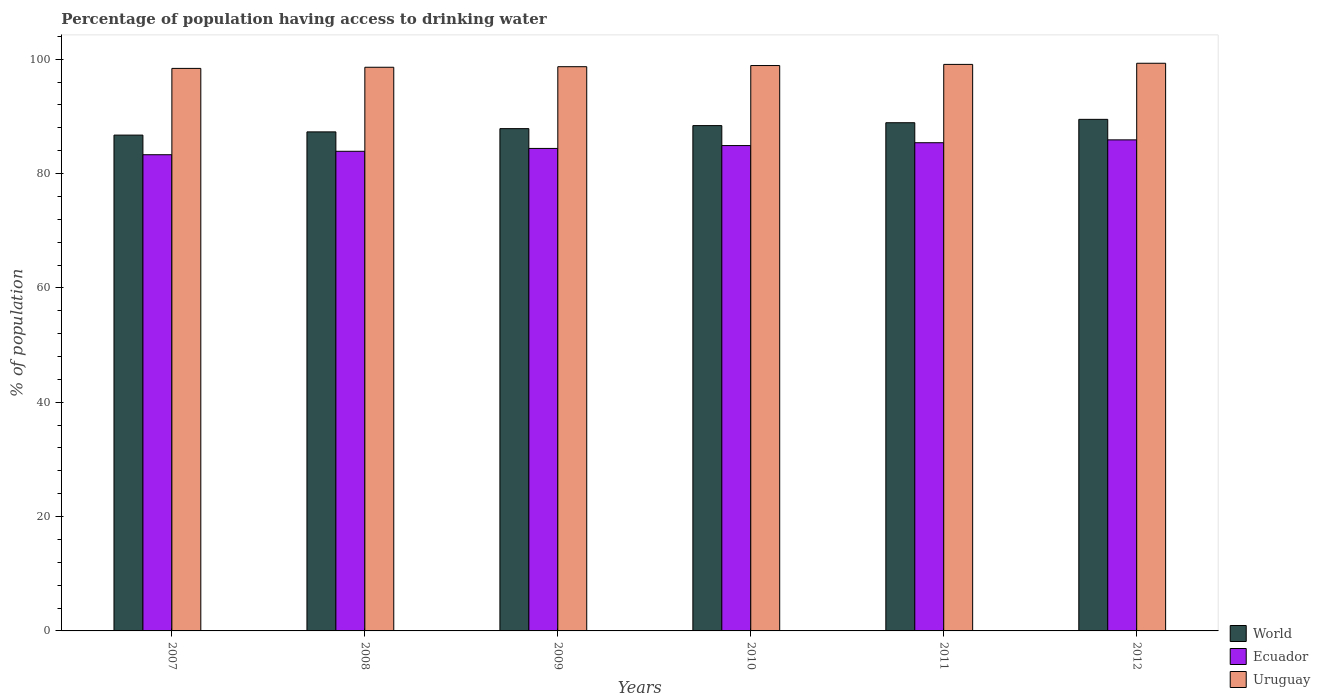How many different coloured bars are there?
Provide a succinct answer. 3. Are the number of bars per tick equal to the number of legend labels?
Offer a very short reply. Yes. How many bars are there on the 5th tick from the left?
Your answer should be compact. 3. How many bars are there on the 6th tick from the right?
Your response must be concise. 3. What is the label of the 4th group of bars from the left?
Your response must be concise. 2010. In how many cases, is the number of bars for a given year not equal to the number of legend labels?
Provide a succinct answer. 0. What is the percentage of population having access to drinking water in World in 2009?
Ensure brevity in your answer.  87.86. Across all years, what is the maximum percentage of population having access to drinking water in Ecuador?
Keep it short and to the point. 85.9. Across all years, what is the minimum percentage of population having access to drinking water in World?
Keep it short and to the point. 86.73. In which year was the percentage of population having access to drinking water in Uruguay minimum?
Your answer should be very brief. 2007. What is the total percentage of population having access to drinking water in Uruguay in the graph?
Provide a short and direct response. 593. What is the difference between the percentage of population having access to drinking water in Uruguay in 2009 and that in 2011?
Offer a terse response. -0.4. What is the difference between the percentage of population having access to drinking water in Uruguay in 2007 and the percentage of population having access to drinking water in World in 2012?
Your answer should be compact. 8.91. What is the average percentage of population having access to drinking water in Uruguay per year?
Keep it short and to the point. 98.83. In the year 2008, what is the difference between the percentage of population having access to drinking water in Ecuador and percentage of population having access to drinking water in World?
Make the answer very short. -3.4. In how many years, is the percentage of population having access to drinking water in World greater than 28 %?
Ensure brevity in your answer.  6. What is the ratio of the percentage of population having access to drinking water in Uruguay in 2008 to that in 2010?
Make the answer very short. 1. Is the percentage of population having access to drinking water in Uruguay in 2008 less than that in 2011?
Your response must be concise. Yes. Is the difference between the percentage of population having access to drinking water in Ecuador in 2010 and 2012 greater than the difference between the percentage of population having access to drinking water in World in 2010 and 2012?
Keep it short and to the point. Yes. What is the difference between the highest and the second highest percentage of population having access to drinking water in Uruguay?
Your answer should be compact. 0.2. What is the difference between the highest and the lowest percentage of population having access to drinking water in World?
Provide a succinct answer. 2.76. What does the 3rd bar from the left in 2010 represents?
Your answer should be compact. Uruguay. What does the 3rd bar from the right in 2011 represents?
Your response must be concise. World. How many years are there in the graph?
Provide a succinct answer. 6. Where does the legend appear in the graph?
Make the answer very short. Bottom right. How many legend labels are there?
Keep it short and to the point. 3. How are the legend labels stacked?
Give a very brief answer. Vertical. What is the title of the graph?
Your answer should be compact. Percentage of population having access to drinking water. Does "Greenland" appear as one of the legend labels in the graph?
Your answer should be compact. No. What is the label or title of the X-axis?
Offer a terse response. Years. What is the label or title of the Y-axis?
Give a very brief answer. % of population. What is the % of population in World in 2007?
Your response must be concise. 86.73. What is the % of population of Ecuador in 2007?
Provide a succinct answer. 83.3. What is the % of population of Uruguay in 2007?
Provide a succinct answer. 98.4. What is the % of population of World in 2008?
Your answer should be compact. 87.3. What is the % of population in Ecuador in 2008?
Offer a terse response. 83.9. What is the % of population of Uruguay in 2008?
Provide a succinct answer. 98.6. What is the % of population in World in 2009?
Your answer should be very brief. 87.86. What is the % of population of Ecuador in 2009?
Offer a very short reply. 84.4. What is the % of population of Uruguay in 2009?
Offer a very short reply. 98.7. What is the % of population of World in 2010?
Your answer should be very brief. 88.39. What is the % of population of Ecuador in 2010?
Make the answer very short. 84.9. What is the % of population in Uruguay in 2010?
Your answer should be very brief. 98.9. What is the % of population of World in 2011?
Your answer should be very brief. 88.9. What is the % of population in Ecuador in 2011?
Give a very brief answer. 85.4. What is the % of population in Uruguay in 2011?
Provide a short and direct response. 99.1. What is the % of population in World in 2012?
Offer a terse response. 89.49. What is the % of population of Ecuador in 2012?
Give a very brief answer. 85.9. What is the % of population of Uruguay in 2012?
Make the answer very short. 99.3. Across all years, what is the maximum % of population of World?
Offer a terse response. 89.49. Across all years, what is the maximum % of population in Ecuador?
Offer a very short reply. 85.9. Across all years, what is the maximum % of population in Uruguay?
Ensure brevity in your answer.  99.3. Across all years, what is the minimum % of population of World?
Offer a terse response. 86.73. Across all years, what is the minimum % of population of Ecuador?
Provide a succinct answer. 83.3. Across all years, what is the minimum % of population of Uruguay?
Provide a short and direct response. 98.4. What is the total % of population in World in the graph?
Offer a terse response. 528.67. What is the total % of population in Ecuador in the graph?
Make the answer very short. 507.8. What is the total % of population in Uruguay in the graph?
Give a very brief answer. 593. What is the difference between the % of population in World in 2007 and that in 2008?
Ensure brevity in your answer.  -0.56. What is the difference between the % of population in Ecuador in 2007 and that in 2008?
Make the answer very short. -0.6. What is the difference between the % of population in Uruguay in 2007 and that in 2008?
Ensure brevity in your answer.  -0.2. What is the difference between the % of population of World in 2007 and that in 2009?
Your answer should be compact. -1.13. What is the difference between the % of population in Ecuador in 2007 and that in 2009?
Your answer should be very brief. -1.1. What is the difference between the % of population in Uruguay in 2007 and that in 2009?
Ensure brevity in your answer.  -0.3. What is the difference between the % of population of World in 2007 and that in 2010?
Make the answer very short. -1.66. What is the difference between the % of population in Uruguay in 2007 and that in 2010?
Ensure brevity in your answer.  -0.5. What is the difference between the % of population of World in 2007 and that in 2011?
Give a very brief answer. -2.17. What is the difference between the % of population of Uruguay in 2007 and that in 2011?
Offer a terse response. -0.7. What is the difference between the % of population of World in 2007 and that in 2012?
Your answer should be very brief. -2.76. What is the difference between the % of population of World in 2008 and that in 2009?
Make the answer very short. -0.57. What is the difference between the % of population of Ecuador in 2008 and that in 2009?
Your answer should be compact. -0.5. What is the difference between the % of population in Uruguay in 2008 and that in 2009?
Offer a very short reply. -0.1. What is the difference between the % of population of World in 2008 and that in 2010?
Offer a terse response. -1.1. What is the difference between the % of population in World in 2008 and that in 2011?
Give a very brief answer. -1.6. What is the difference between the % of population in World in 2008 and that in 2012?
Your answer should be very brief. -2.19. What is the difference between the % of population of Ecuador in 2008 and that in 2012?
Offer a terse response. -2. What is the difference between the % of population of World in 2009 and that in 2010?
Make the answer very short. -0.53. What is the difference between the % of population of Uruguay in 2009 and that in 2010?
Make the answer very short. -0.2. What is the difference between the % of population of World in 2009 and that in 2011?
Your answer should be very brief. -1.03. What is the difference between the % of population in Uruguay in 2009 and that in 2011?
Keep it short and to the point. -0.4. What is the difference between the % of population of World in 2009 and that in 2012?
Your answer should be very brief. -1.62. What is the difference between the % of population in Ecuador in 2009 and that in 2012?
Your answer should be very brief. -1.5. What is the difference between the % of population in World in 2010 and that in 2011?
Your answer should be compact. -0.5. What is the difference between the % of population of Uruguay in 2010 and that in 2011?
Offer a terse response. -0.2. What is the difference between the % of population in World in 2010 and that in 2012?
Make the answer very short. -1.09. What is the difference between the % of population in World in 2011 and that in 2012?
Offer a terse response. -0.59. What is the difference between the % of population of Ecuador in 2011 and that in 2012?
Provide a succinct answer. -0.5. What is the difference between the % of population in World in 2007 and the % of population in Ecuador in 2008?
Provide a short and direct response. 2.83. What is the difference between the % of population in World in 2007 and the % of population in Uruguay in 2008?
Make the answer very short. -11.87. What is the difference between the % of population in Ecuador in 2007 and the % of population in Uruguay in 2008?
Ensure brevity in your answer.  -15.3. What is the difference between the % of population of World in 2007 and the % of population of Ecuador in 2009?
Offer a very short reply. 2.33. What is the difference between the % of population in World in 2007 and the % of population in Uruguay in 2009?
Your answer should be very brief. -11.97. What is the difference between the % of population in Ecuador in 2007 and the % of population in Uruguay in 2009?
Provide a short and direct response. -15.4. What is the difference between the % of population in World in 2007 and the % of population in Ecuador in 2010?
Your answer should be compact. 1.83. What is the difference between the % of population of World in 2007 and the % of population of Uruguay in 2010?
Make the answer very short. -12.17. What is the difference between the % of population of Ecuador in 2007 and the % of population of Uruguay in 2010?
Give a very brief answer. -15.6. What is the difference between the % of population in World in 2007 and the % of population in Ecuador in 2011?
Give a very brief answer. 1.33. What is the difference between the % of population of World in 2007 and the % of population of Uruguay in 2011?
Ensure brevity in your answer.  -12.37. What is the difference between the % of population of Ecuador in 2007 and the % of population of Uruguay in 2011?
Offer a terse response. -15.8. What is the difference between the % of population in World in 2007 and the % of population in Ecuador in 2012?
Provide a short and direct response. 0.83. What is the difference between the % of population in World in 2007 and the % of population in Uruguay in 2012?
Offer a terse response. -12.57. What is the difference between the % of population of Ecuador in 2007 and the % of population of Uruguay in 2012?
Ensure brevity in your answer.  -16. What is the difference between the % of population of World in 2008 and the % of population of Ecuador in 2009?
Your answer should be very brief. 2.9. What is the difference between the % of population in World in 2008 and the % of population in Uruguay in 2009?
Ensure brevity in your answer.  -11.4. What is the difference between the % of population in Ecuador in 2008 and the % of population in Uruguay in 2009?
Make the answer very short. -14.8. What is the difference between the % of population of World in 2008 and the % of population of Ecuador in 2010?
Make the answer very short. 2.4. What is the difference between the % of population in World in 2008 and the % of population in Uruguay in 2010?
Make the answer very short. -11.6. What is the difference between the % of population in Ecuador in 2008 and the % of population in Uruguay in 2010?
Your answer should be very brief. -15. What is the difference between the % of population of World in 2008 and the % of population of Ecuador in 2011?
Give a very brief answer. 1.9. What is the difference between the % of population of World in 2008 and the % of population of Uruguay in 2011?
Offer a terse response. -11.8. What is the difference between the % of population in Ecuador in 2008 and the % of population in Uruguay in 2011?
Provide a short and direct response. -15.2. What is the difference between the % of population of World in 2008 and the % of population of Ecuador in 2012?
Keep it short and to the point. 1.4. What is the difference between the % of population of World in 2008 and the % of population of Uruguay in 2012?
Your answer should be very brief. -12. What is the difference between the % of population of Ecuador in 2008 and the % of population of Uruguay in 2012?
Your response must be concise. -15.4. What is the difference between the % of population in World in 2009 and the % of population in Ecuador in 2010?
Give a very brief answer. 2.96. What is the difference between the % of population of World in 2009 and the % of population of Uruguay in 2010?
Your answer should be compact. -11.04. What is the difference between the % of population in World in 2009 and the % of population in Ecuador in 2011?
Provide a succinct answer. 2.46. What is the difference between the % of population of World in 2009 and the % of population of Uruguay in 2011?
Keep it short and to the point. -11.24. What is the difference between the % of population of Ecuador in 2009 and the % of population of Uruguay in 2011?
Give a very brief answer. -14.7. What is the difference between the % of population of World in 2009 and the % of population of Ecuador in 2012?
Provide a short and direct response. 1.96. What is the difference between the % of population of World in 2009 and the % of population of Uruguay in 2012?
Provide a succinct answer. -11.44. What is the difference between the % of population in Ecuador in 2009 and the % of population in Uruguay in 2012?
Offer a terse response. -14.9. What is the difference between the % of population of World in 2010 and the % of population of Ecuador in 2011?
Your response must be concise. 2.99. What is the difference between the % of population in World in 2010 and the % of population in Uruguay in 2011?
Offer a terse response. -10.71. What is the difference between the % of population in World in 2010 and the % of population in Ecuador in 2012?
Make the answer very short. 2.49. What is the difference between the % of population of World in 2010 and the % of population of Uruguay in 2012?
Offer a terse response. -10.91. What is the difference between the % of population of Ecuador in 2010 and the % of population of Uruguay in 2012?
Make the answer very short. -14.4. What is the difference between the % of population of World in 2011 and the % of population of Ecuador in 2012?
Your answer should be compact. 3. What is the difference between the % of population in World in 2011 and the % of population in Uruguay in 2012?
Keep it short and to the point. -10.4. What is the average % of population of World per year?
Provide a succinct answer. 88.11. What is the average % of population of Ecuador per year?
Your answer should be very brief. 84.63. What is the average % of population in Uruguay per year?
Make the answer very short. 98.83. In the year 2007, what is the difference between the % of population of World and % of population of Ecuador?
Your answer should be compact. 3.43. In the year 2007, what is the difference between the % of population in World and % of population in Uruguay?
Offer a terse response. -11.67. In the year 2007, what is the difference between the % of population in Ecuador and % of population in Uruguay?
Make the answer very short. -15.1. In the year 2008, what is the difference between the % of population in World and % of population in Ecuador?
Your answer should be very brief. 3.4. In the year 2008, what is the difference between the % of population in World and % of population in Uruguay?
Offer a very short reply. -11.3. In the year 2008, what is the difference between the % of population of Ecuador and % of population of Uruguay?
Your response must be concise. -14.7. In the year 2009, what is the difference between the % of population in World and % of population in Ecuador?
Make the answer very short. 3.46. In the year 2009, what is the difference between the % of population of World and % of population of Uruguay?
Give a very brief answer. -10.84. In the year 2009, what is the difference between the % of population in Ecuador and % of population in Uruguay?
Offer a terse response. -14.3. In the year 2010, what is the difference between the % of population in World and % of population in Ecuador?
Your answer should be very brief. 3.49. In the year 2010, what is the difference between the % of population of World and % of population of Uruguay?
Offer a terse response. -10.51. In the year 2010, what is the difference between the % of population in Ecuador and % of population in Uruguay?
Your answer should be compact. -14. In the year 2011, what is the difference between the % of population in World and % of population in Ecuador?
Offer a terse response. 3.5. In the year 2011, what is the difference between the % of population in World and % of population in Uruguay?
Your answer should be very brief. -10.2. In the year 2011, what is the difference between the % of population of Ecuador and % of population of Uruguay?
Offer a terse response. -13.7. In the year 2012, what is the difference between the % of population in World and % of population in Ecuador?
Provide a short and direct response. 3.59. In the year 2012, what is the difference between the % of population in World and % of population in Uruguay?
Ensure brevity in your answer.  -9.81. What is the ratio of the % of population in World in 2007 to that in 2008?
Your response must be concise. 0.99. What is the ratio of the % of population of World in 2007 to that in 2009?
Give a very brief answer. 0.99. What is the ratio of the % of population of Ecuador in 2007 to that in 2009?
Keep it short and to the point. 0.99. What is the ratio of the % of population in World in 2007 to that in 2010?
Keep it short and to the point. 0.98. What is the ratio of the % of population of Ecuador in 2007 to that in 2010?
Offer a terse response. 0.98. What is the ratio of the % of population of Uruguay in 2007 to that in 2010?
Your response must be concise. 0.99. What is the ratio of the % of population of World in 2007 to that in 2011?
Your response must be concise. 0.98. What is the ratio of the % of population of Ecuador in 2007 to that in 2011?
Your answer should be compact. 0.98. What is the ratio of the % of population in World in 2007 to that in 2012?
Offer a very short reply. 0.97. What is the ratio of the % of population in Ecuador in 2007 to that in 2012?
Provide a succinct answer. 0.97. What is the ratio of the % of population of Uruguay in 2007 to that in 2012?
Give a very brief answer. 0.99. What is the ratio of the % of population in World in 2008 to that in 2009?
Your answer should be very brief. 0.99. What is the ratio of the % of population in Uruguay in 2008 to that in 2009?
Ensure brevity in your answer.  1. What is the ratio of the % of population of World in 2008 to that in 2010?
Offer a very short reply. 0.99. What is the ratio of the % of population of Uruguay in 2008 to that in 2010?
Keep it short and to the point. 1. What is the ratio of the % of population of World in 2008 to that in 2011?
Provide a short and direct response. 0.98. What is the ratio of the % of population in Ecuador in 2008 to that in 2011?
Give a very brief answer. 0.98. What is the ratio of the % of population in Uruguay in 2008 to that in 2011?
Ensure brevity in your answer.  0.99. What is the ratio of the % of population in World in 2008 to that in 2012?
Your answer should be compact. 0.98. What is the ratio of the % of population in Ecuador in 2008 to that in 2012?
Your response must be concise. 0.98. What is the ratio of the % of population in Uruguay in 2008 to that in 2012?
Ensure brevity in your answer.  0.99. What is the ratio of the % of population of World in 2009 to that in 2010?
Make the answer very short. 0.99. What is the ratio of the % of population of World in 2009 to that in 2011?
Offer a terse response. 0.99. What is the ratio of the % of population of Ecuador in 2009 to that in 2011?
Your answer should be very brief. 0.99. What is the ratio of the % of population of Uruguay in 2009 to that in 2011?
Give a very brief answer. 1. What is the ratio of the % of population of World in 2009 to that in 2012?
Ensure brevity in your answer.  0.98. What is the ratio of the % of population in Ecuador in 2009 to that in 2012?
Offer a very short reply. 0.98. What is the ratio of the % of population of Ecuador in 2010 to that in 2011?
Give a very brief answer. 0.99. What is the ratio of the % of population of Ecuador in 2010 to that in 2012?
Keep it short and to the point. 0.99. What is the ratio of the % of population of Ecuador in 2011 to that in 2012?
Ensure brevity in your answer.  0.99. What is the difference between the highest and the second highest % of population of World?
Your response must be concise. 0.59. What is the difference between the highest and the lowest % of population in World?
Make the answer very short. 2.76. What is the difference between the highest and the lowest % of population in Uruguay?
Provide a succinct answer. 0.9. 